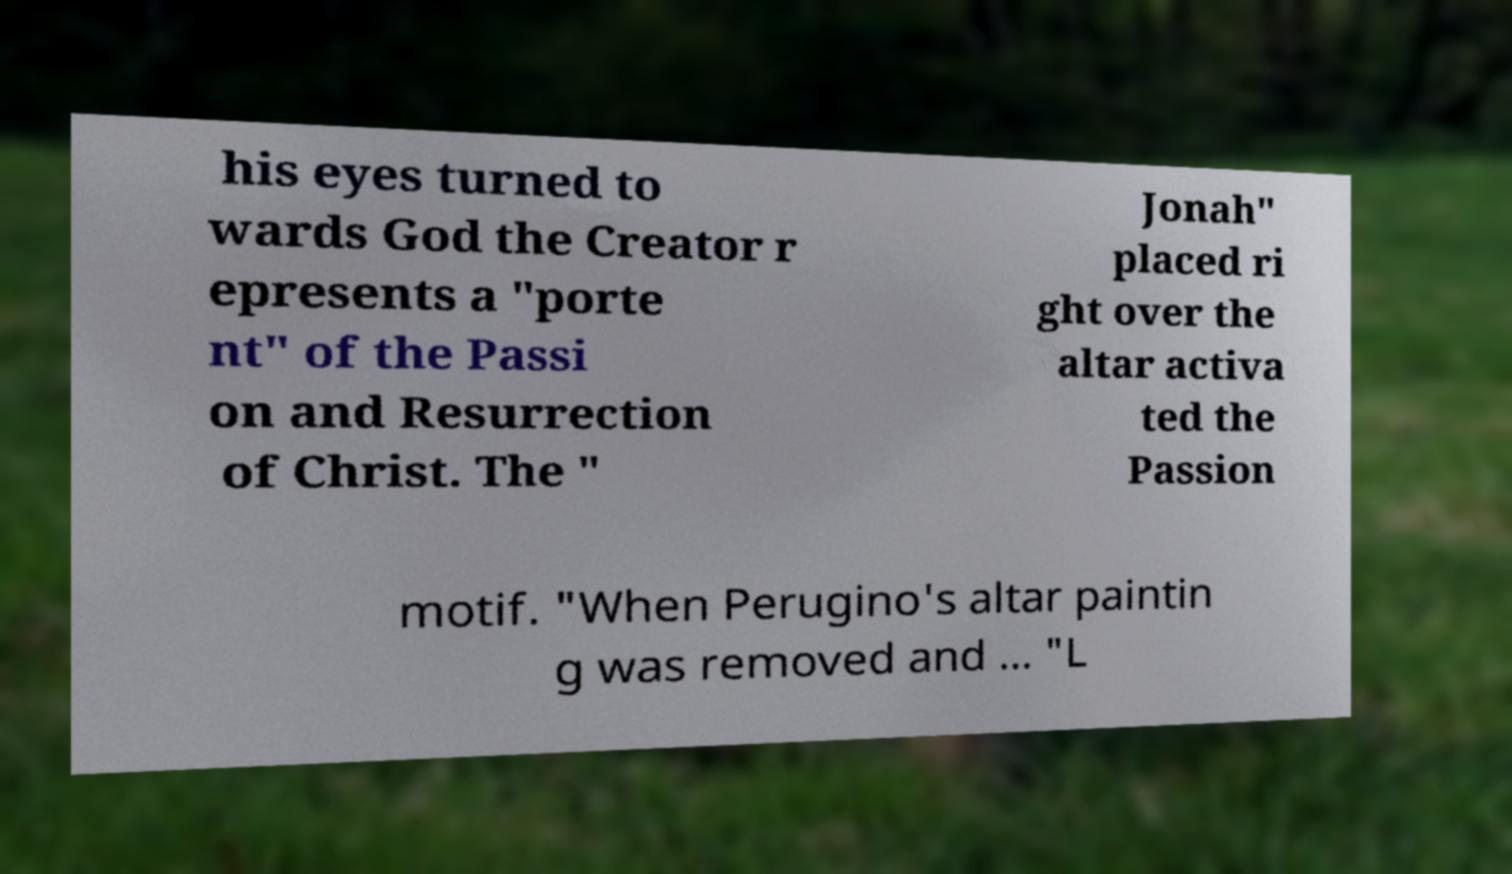I need the written content from this picture converted into text. Can you do that? his eyes turned to wards God the Creator r epresents a "porte nt" of the Passi on and Resurrection of Christ. The " Jonah" placed ri ght over the altar activa ted the Passion motif. "When Perugino's altar paintin g was removed and ... "L 